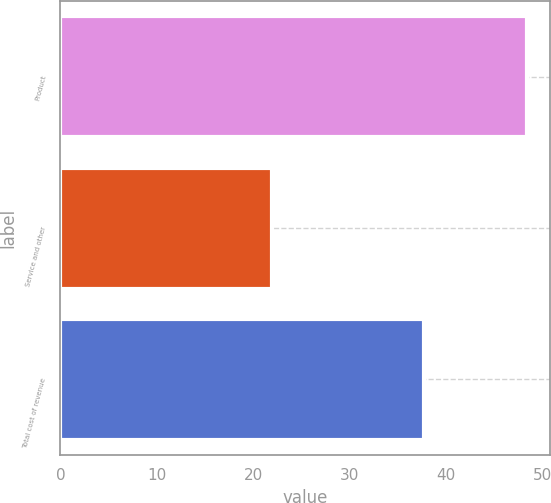Convert chart to OTSL. <chart><loc_0><loc_0><loc_500><loc_500><bar_chart><fcel>Product<fcel>Service and other<fcel>Total cost of revenue<nl><fcel>48.4<fcel>21.9<fcel>37.7<nl></chart> 